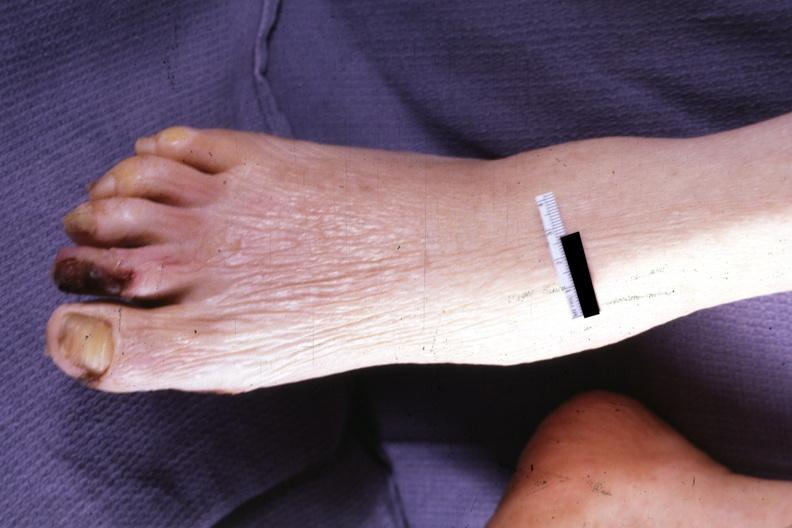s malignant adenoma present?
Answer the question using a single word or phrase. No 